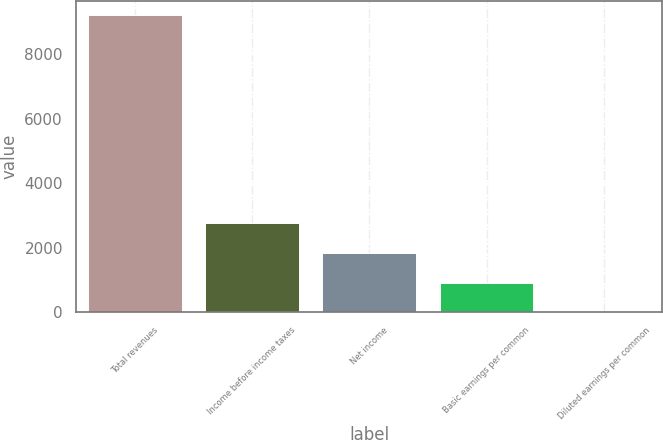<chart> <loc_0><loc_0><loc_500><loc_500><bar_chart><fcel>Total revenues<fcel>Income before income taxes<fcel>Net income<fcel>Basic earnings per common<fcel>Diluted earnings per common<nl><fcel>9191<fcel>2758.59<fcel>1839.68<fcel>920.77<fcel>1.86<nl></chart> 